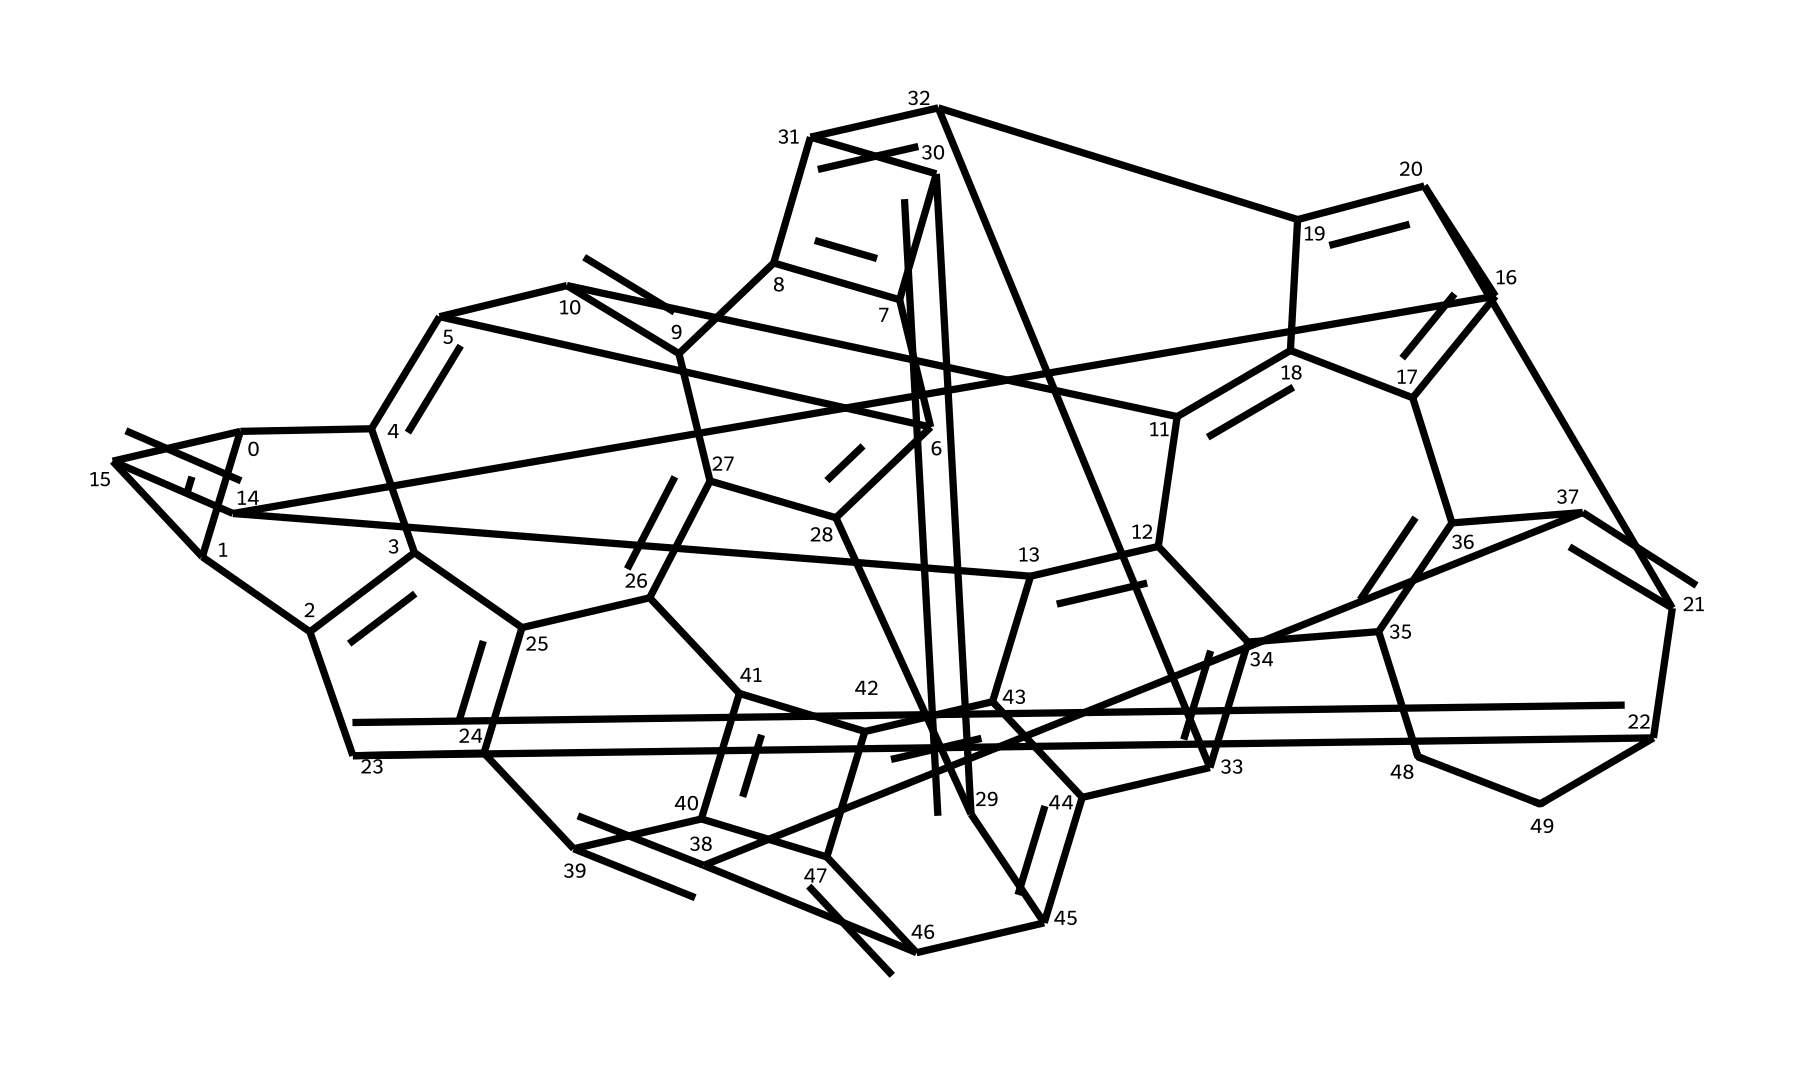What is the total number of carbon atoms in buckminsterfullerene C60? The SMILES representation indicates the structure of buckminsterfullerene, which is explicitly denoted as C60. This means there are 60 carbon atoms.
Answer: 60 How many double bonds are present in this structure? Analyzing the SMILES notation for buckminsterfullerene, it can be observed that it contains alternating single and double bonds. There are 30 pairs of C=C bonds, indicating the presence of 30 double bonds.
Answer: 30 What geometric shape does buckminsterfullerene resemble? The arrangement of carbon atoms in buckminsterfullerene creates a structure that closely resembles a soccer ball, which has aicosahedral symmetry.
Answer: soccer ball How many rings are formed in the structure of buckminsterfullerene? In the buckminsterfullerene structure, there are 12 pentagonal rings and 20 hexagonal rings, totaling 32 rings in the entire molecule.
Answer: 32 Is buckminsterfullerene a type of fullerene? Buckminsterfullerene is specifically classified as a fullerene, which is a form of carbon arranged in a spherical or ellipsoidal shape.
Answer: yes What type of hybridization is present in the carbon atoms of C60? The carbon atoms in buckminsterfullerene exhibit sp2 hybridization, which is typical for carbon atoms involved in double bonding and planar structures.
Answer: sp2 